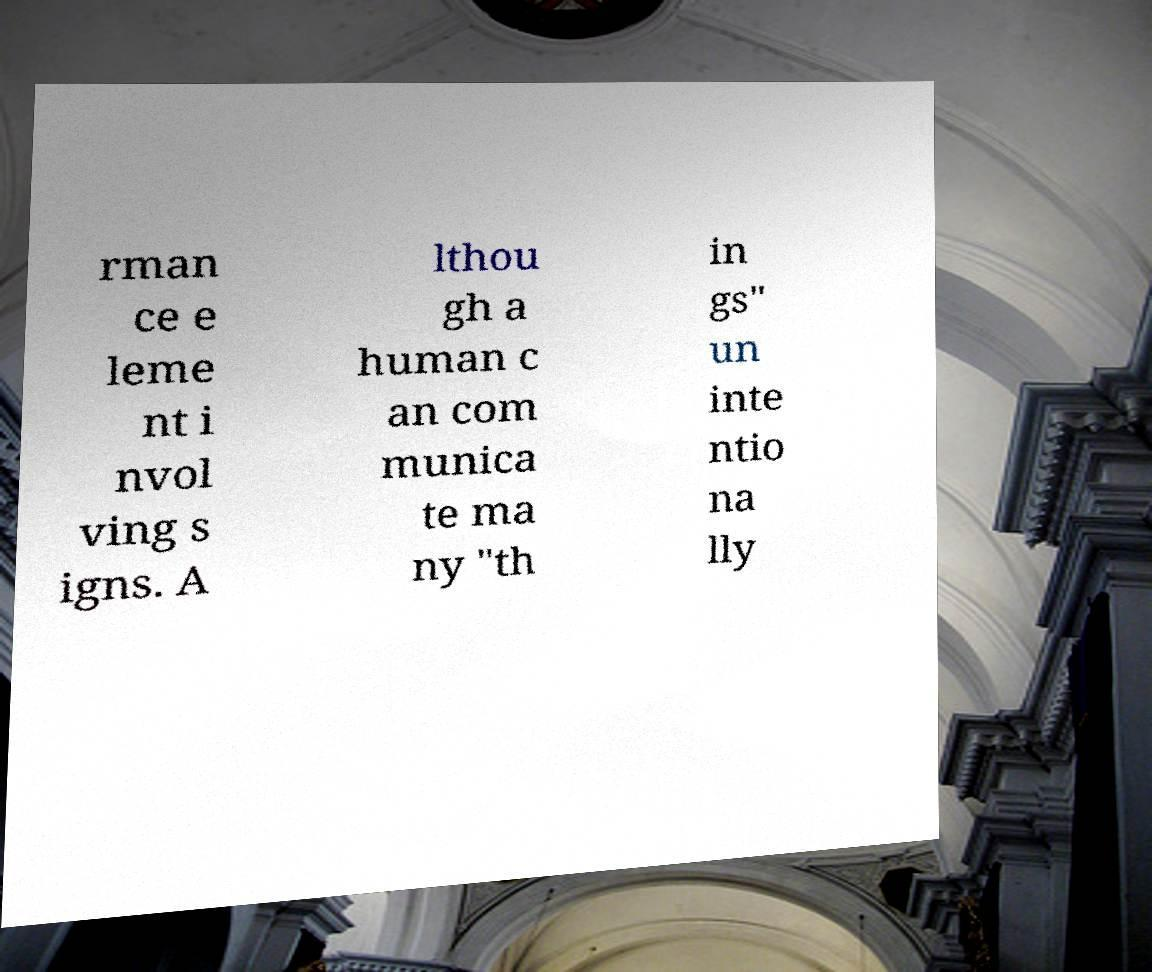I need the written content from this picture converted into text. Can you do that? rman ce e leme nt i nvol ving s igns. A lthou gh a human c an com munica te ma ny "th in gs" un inte ntio na lly 